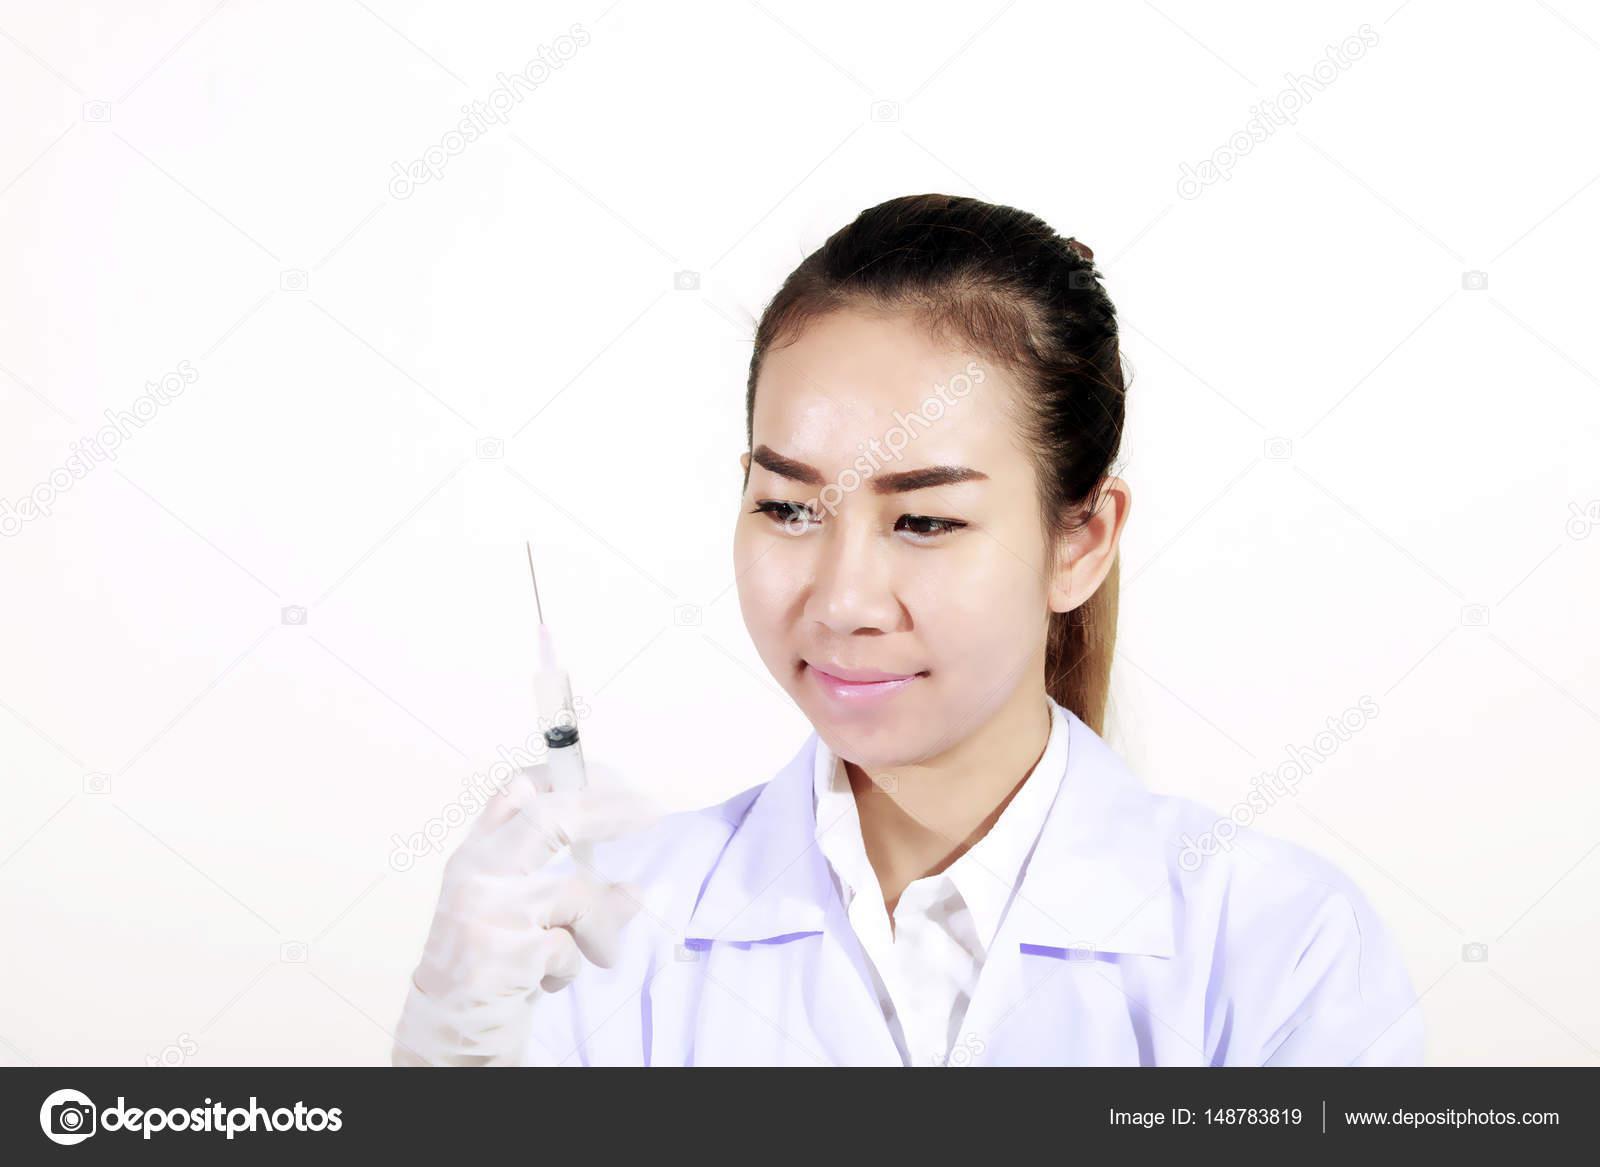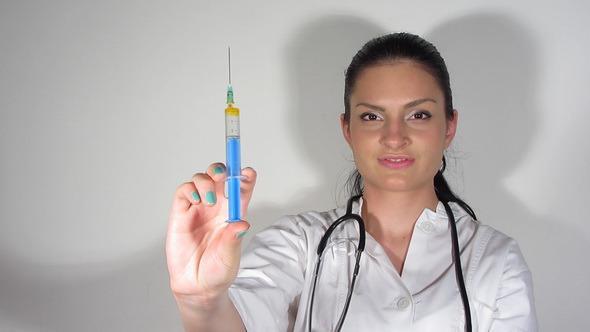The first image is the image on the left, the second image is the image on the right. Considering the images on both sides, is "The left and right image contains the same number of women holding needles." valid? Answer yes or no. Yes. The first image is the image on the left, the second image is the image on the right. Evaluate the accuracy of this statement regarding the images: "Both doctors are women holding needles.". Is it true? Answer yes or no. Yes. 